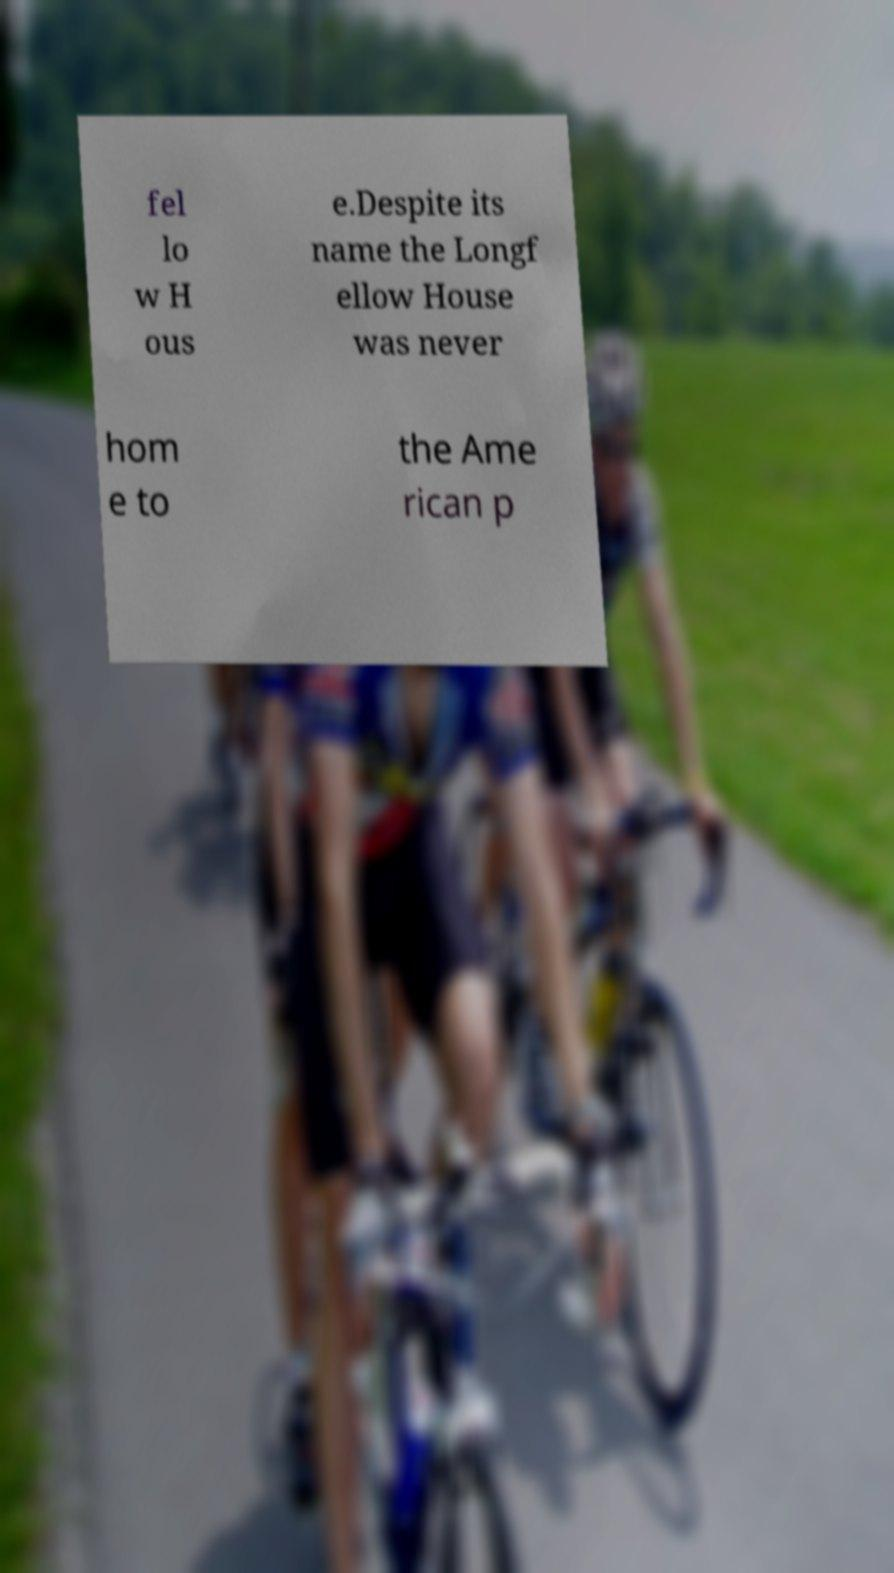I need the written content from this picture converted into text. Can you do that? fel lo w H ous e.Despite its name the Longf ellow House was never hom e to the Ame rican p 